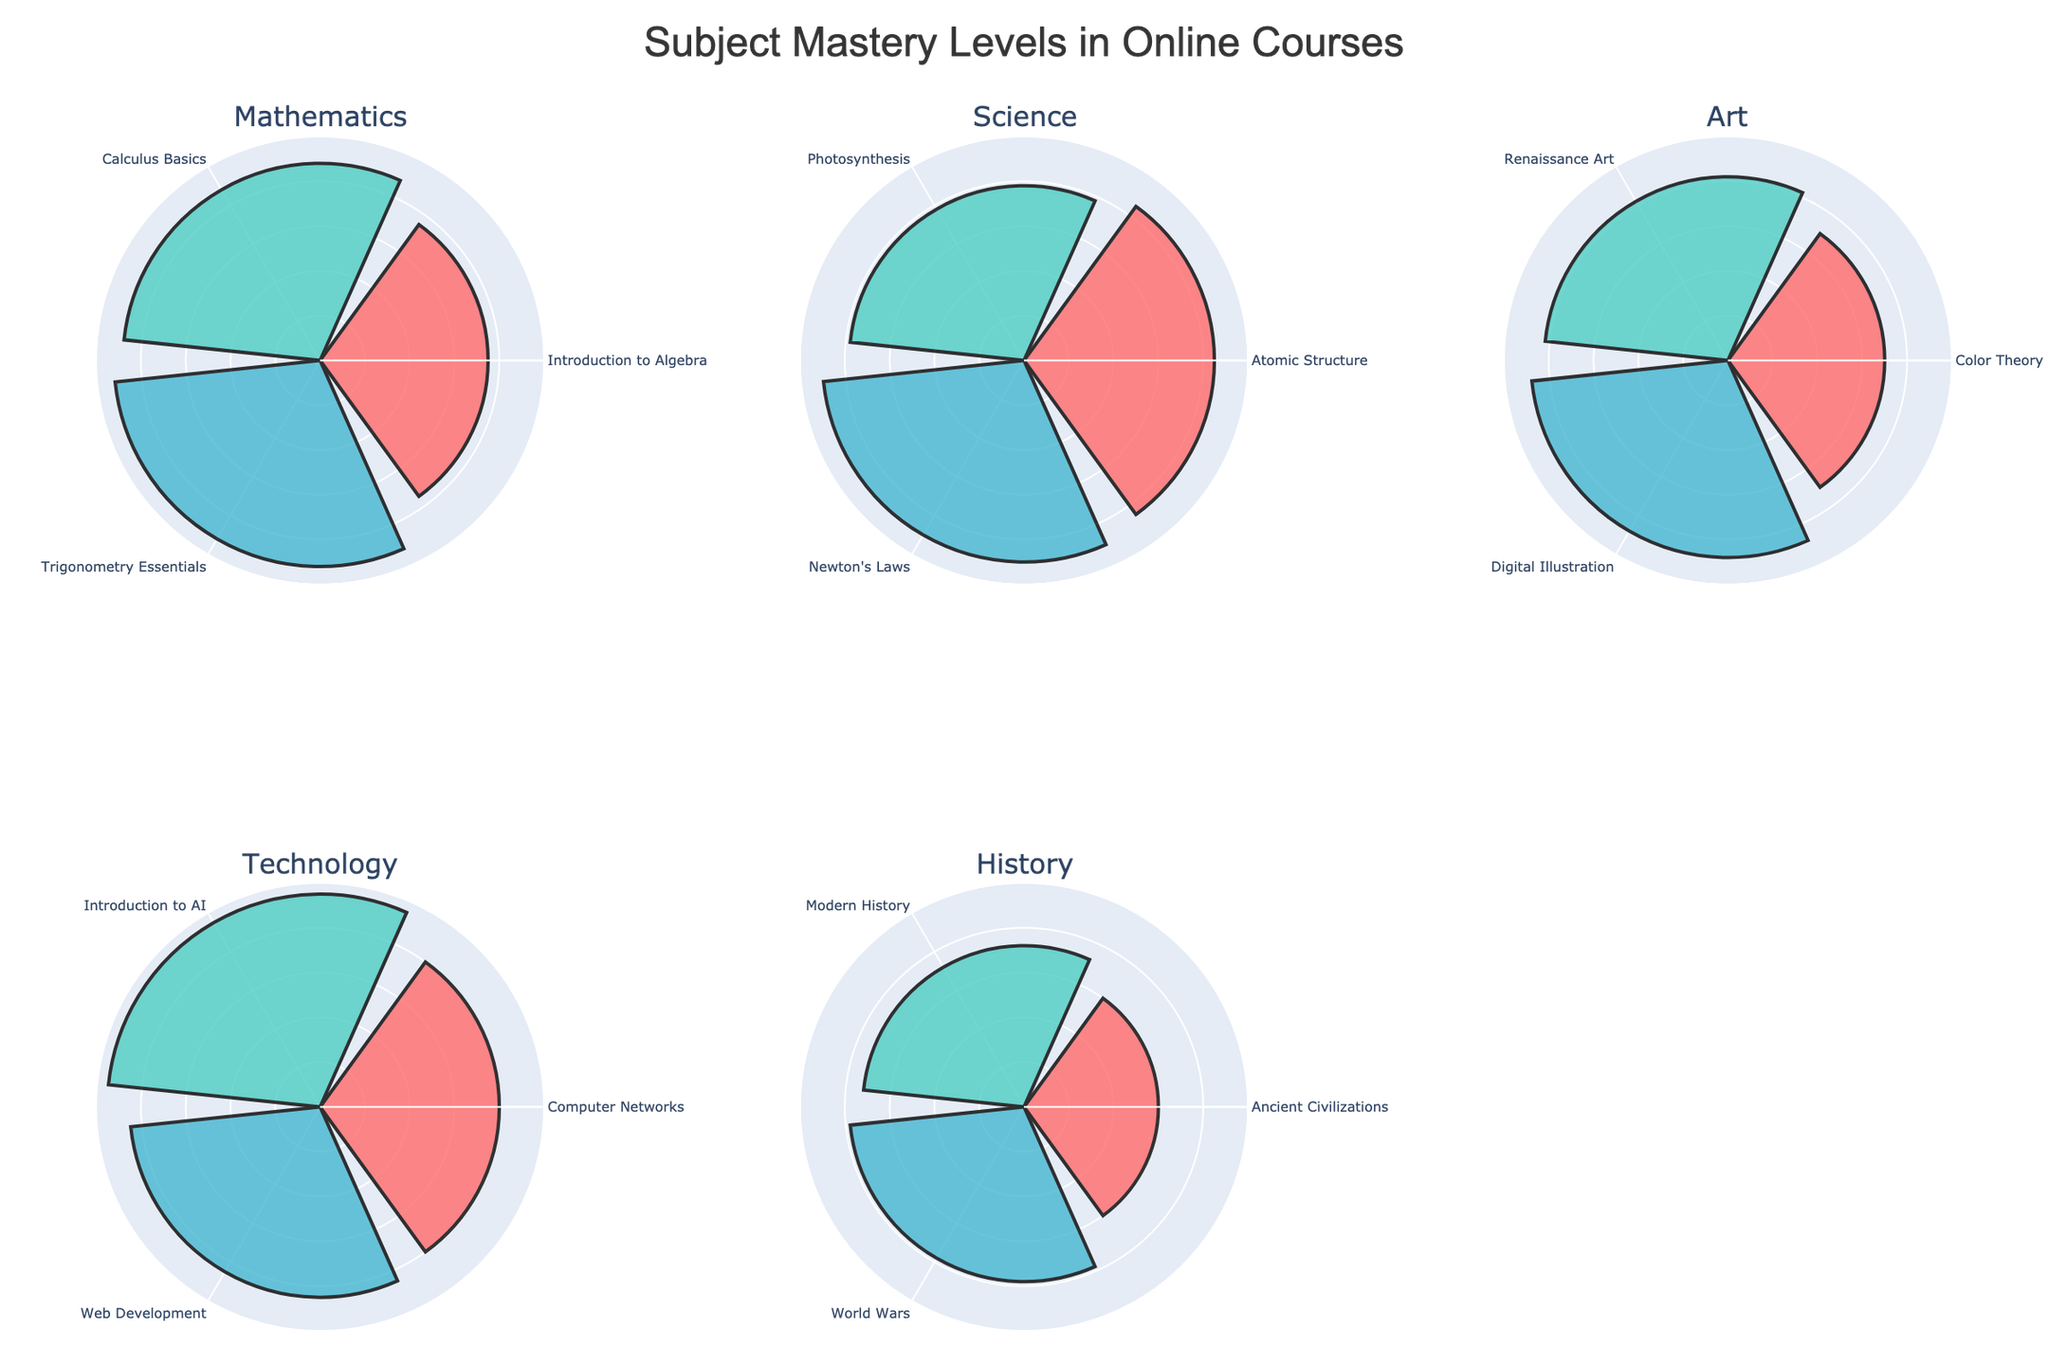How many online courses are represented in the figure? The figure has subplots for each unique course. By looking at the titles of the subplots, we can count the total number of online courses represented.
Answer: 5 Which course has the highest mastery level in its subplot? To determine which course has the highest mastery level, visually inspect the tallest bar (r value) across all subplots.
Answer: Technology What is the average mastery level for Mathematics courses? To find the average mastery level for Mathematics, add the mastery levels for "Introduction to Algebra" (75), "Calculus Basics" (88), and "Trigonometry Essentials" (92), and divide by the number of entries, which is 3. (75 + 88 + 92) / 3 = 255 / 3.
Answer: 85 In which course does "Student_001" have the lowest mastery level? Check the mastery levels for "Student_001" in each course by looking at the radial values in each subplot. The lowest value must be compared across all courses.
Answer: History Compare "Student_003"'s mastery levels in Art and Science. Which one is higher? Locate "Student_003"'s mastery levels in the Art and Science subplots. For Art, the mastery level is 88 (Digital Illustration), and for Science, it is 90 (Newton's Laws). Comparing these values, Science has a higher level.
Answer: Science Which animation in the Technology course has the highest mastery level? Inspect the "Technology" subplot and check each animation's bar height. The highest bar represents "Introduction to AI".
Answer: Introduction to AI What is the total mastery level for all students in the History course? Sum the mastery levels for History: "Ancient Civilizations" (60), "Modern History" (72), and "World Wars" (78). The calculation is 60 + 72 + 78.
Answer: 210 Is the highest mastery level in the Science course greater than the highest mastery level in the Art course? Compare the highest mastery levels in Science (90 for Newton's Laws) and Art (88 for Digital Illustration).
Answer: Yes Which course has the most varying mastery levels based on visual inspection? Compare the spread (difference between the highest and lowest radial values) of mastery levels across all subplots. The course with the largest variation visually will be identified.
Answer: History 